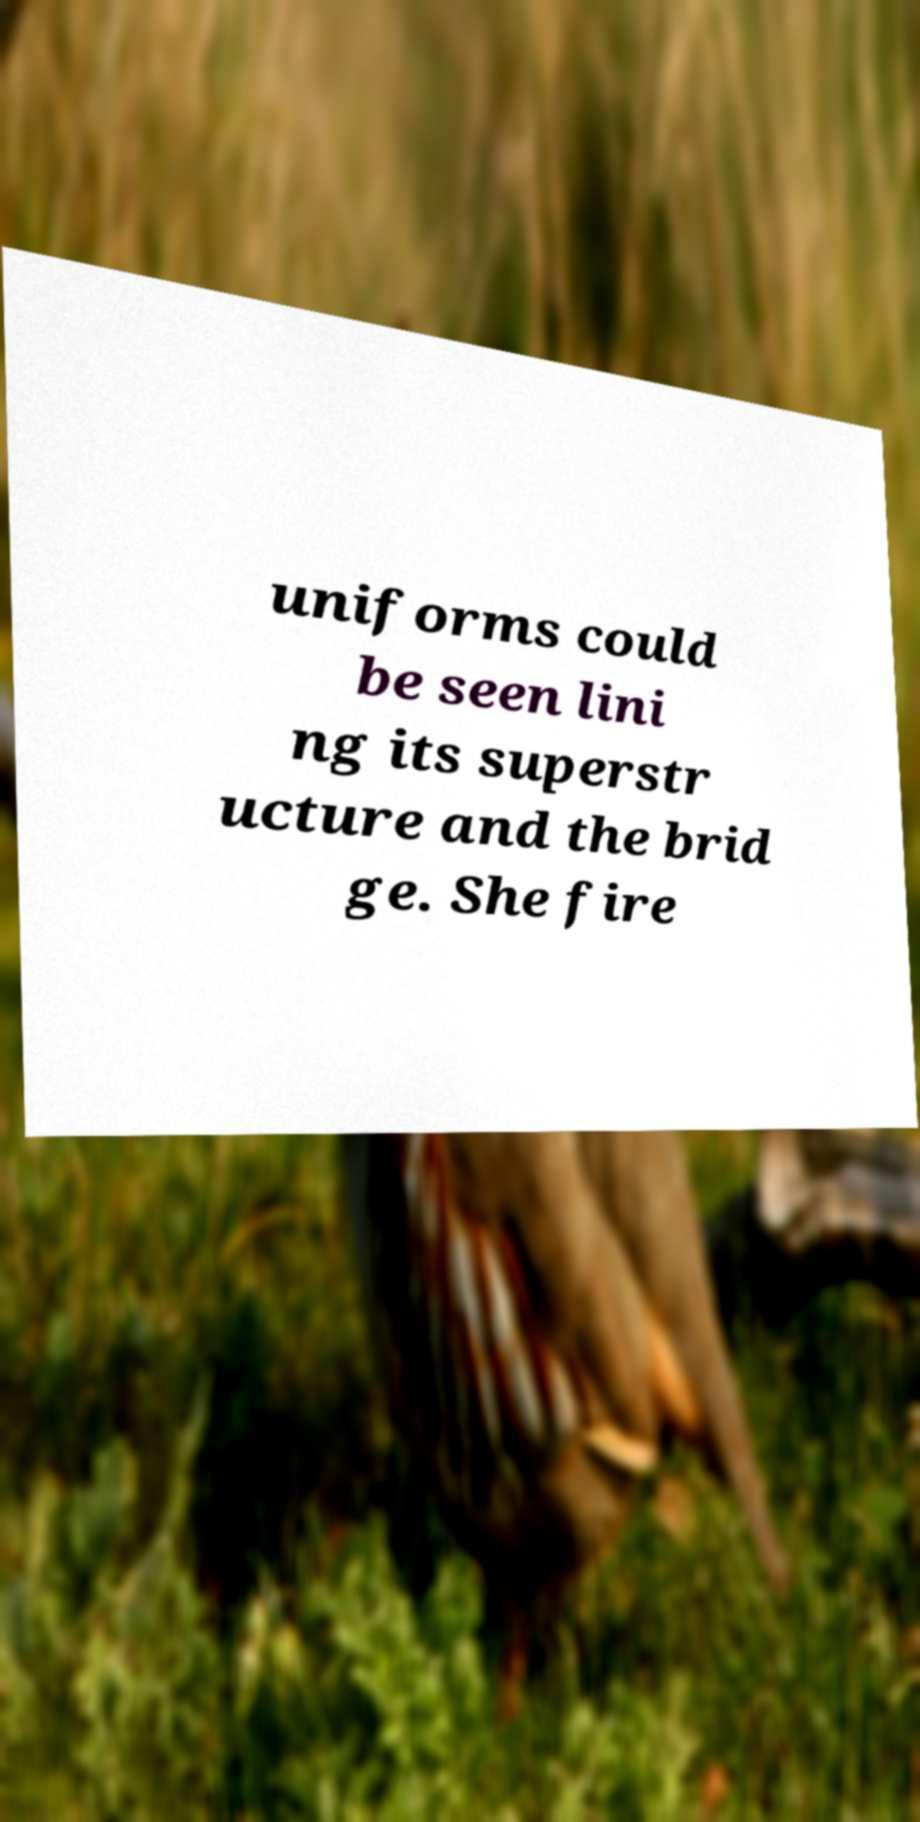Please identify and transcribe the text found in this image. uniforms could be seen lini ng its superstr ucture and the brid ge. She fire 